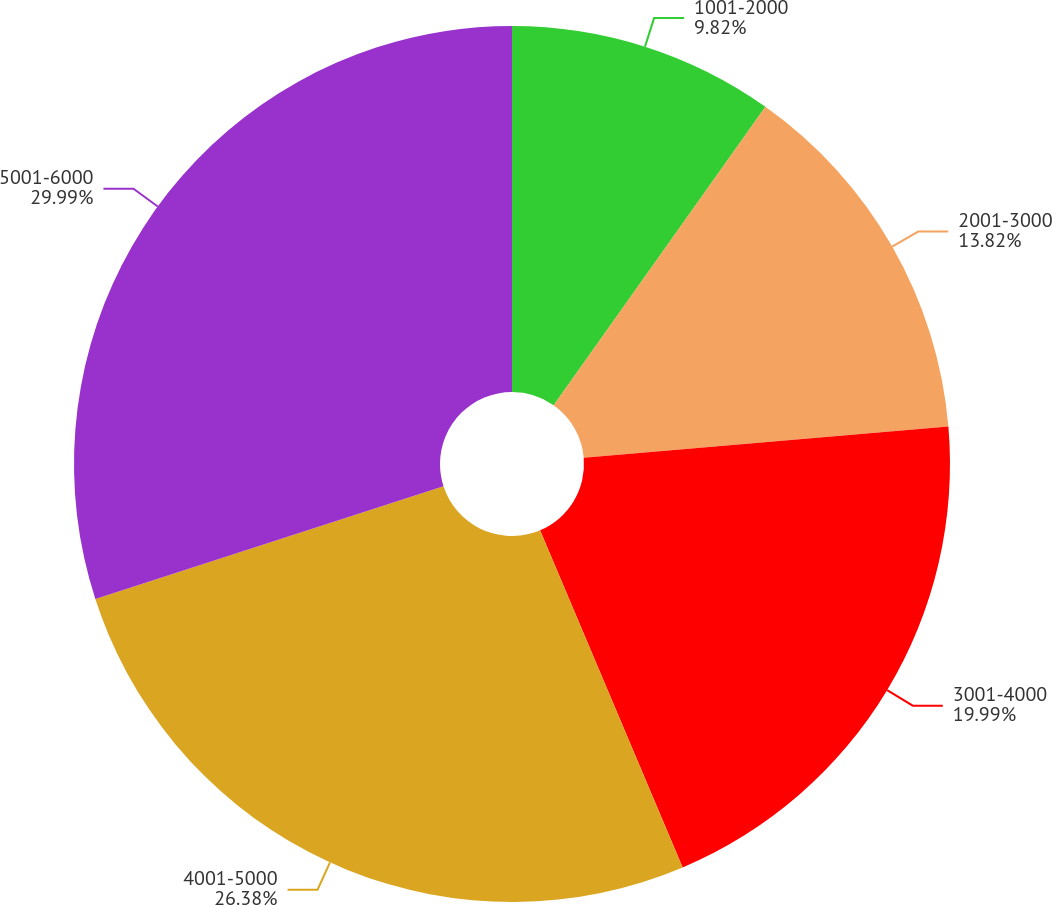Convert chart to OTSL. <chart><loc_0><loc_0><loc_500><loc_500><pie_chart><fcel>1001-2000<fcel>2001-3000<fcel>3001-4000<fcel>4001-5000<fcel>5001-6000<nl><fcel>9.82%<fcel>13.82%<fcel>19.99%<fcel>26.38%<fcel>29.99%<nl></chart> 